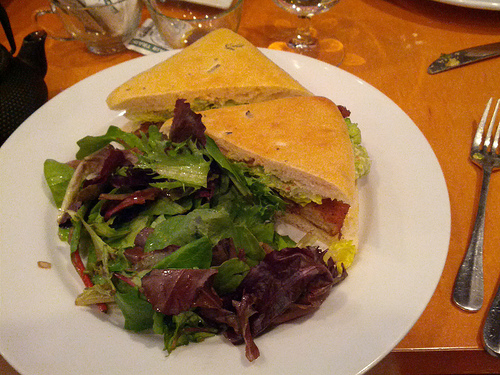Is the cup to the left or to the right of the glasses? The cup is on the left side of the glasses, as viewed from the perspective of the photograph. 